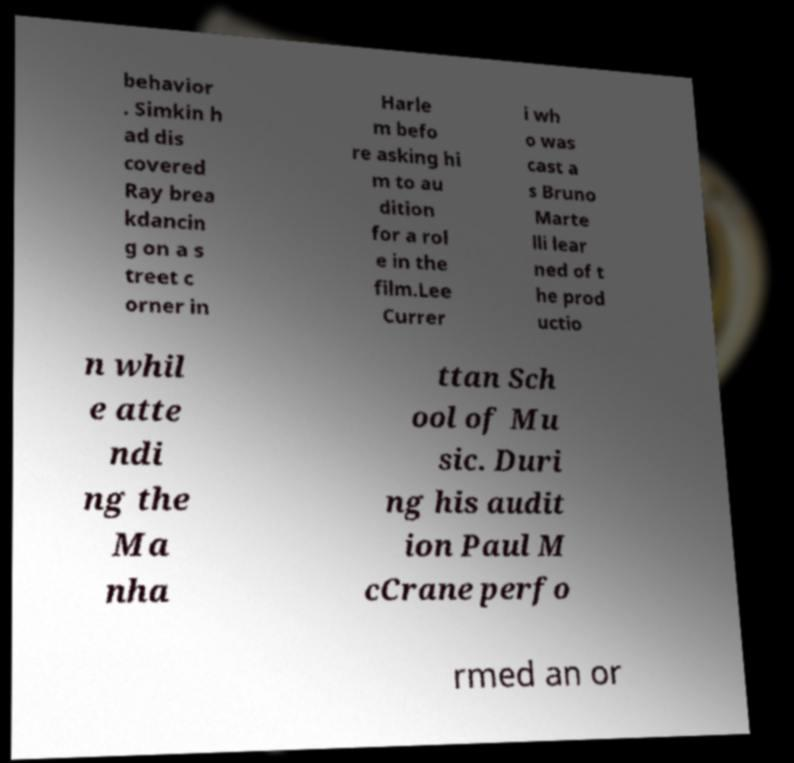What messages or text are displayed in this image? I need them in a readable, typed format. behavior . Simkin h ad dis covered Ray brea kdancin g on a s treet c orner in Harle m befo re asking hi m to au dition for a rol e in the film.Lee Currer i wh o was cast a s Bruno Marte lli lear ned of t he prod uctio n whil e atte ndi ng the Ma nha ttan Sch ool of Mu sic. Duri ng his audit ion Paul M cCrane perfo rmed an or 